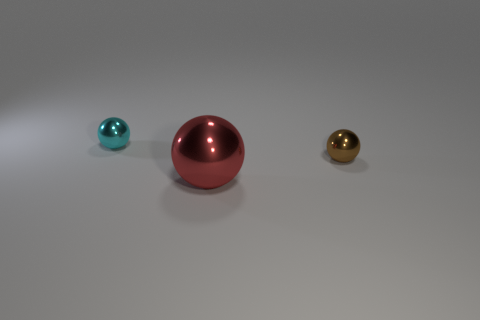Add 2 small gray matte things. How many objects exist? 5 Subtract all tiny spheres. How many spheres are left? 1 Subtract 0 gray blocks. How many objects are left? 3 Subtract all cyan balls. Subtract all red cylinders. How many balls are left? 2 Subtract all cyan blocks. How many green balls are left? 0 Subtract all small cyan metal things. Subtract all tiny cyan metal balls. How many objects are left? 1 Add 2 small cyan objects. How many small cyan objects are left? 3 Add 1 cyan cylinders. How many cyan cylinders exist? 1 